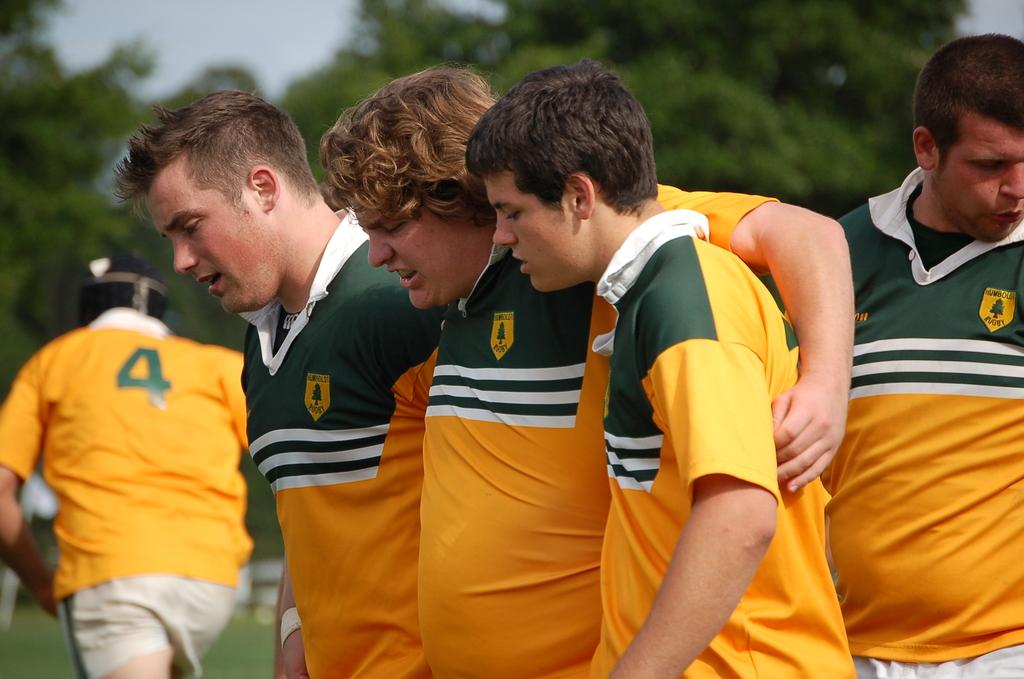What's the player number of the big guy running away?
Offer a very short reply. 4. 